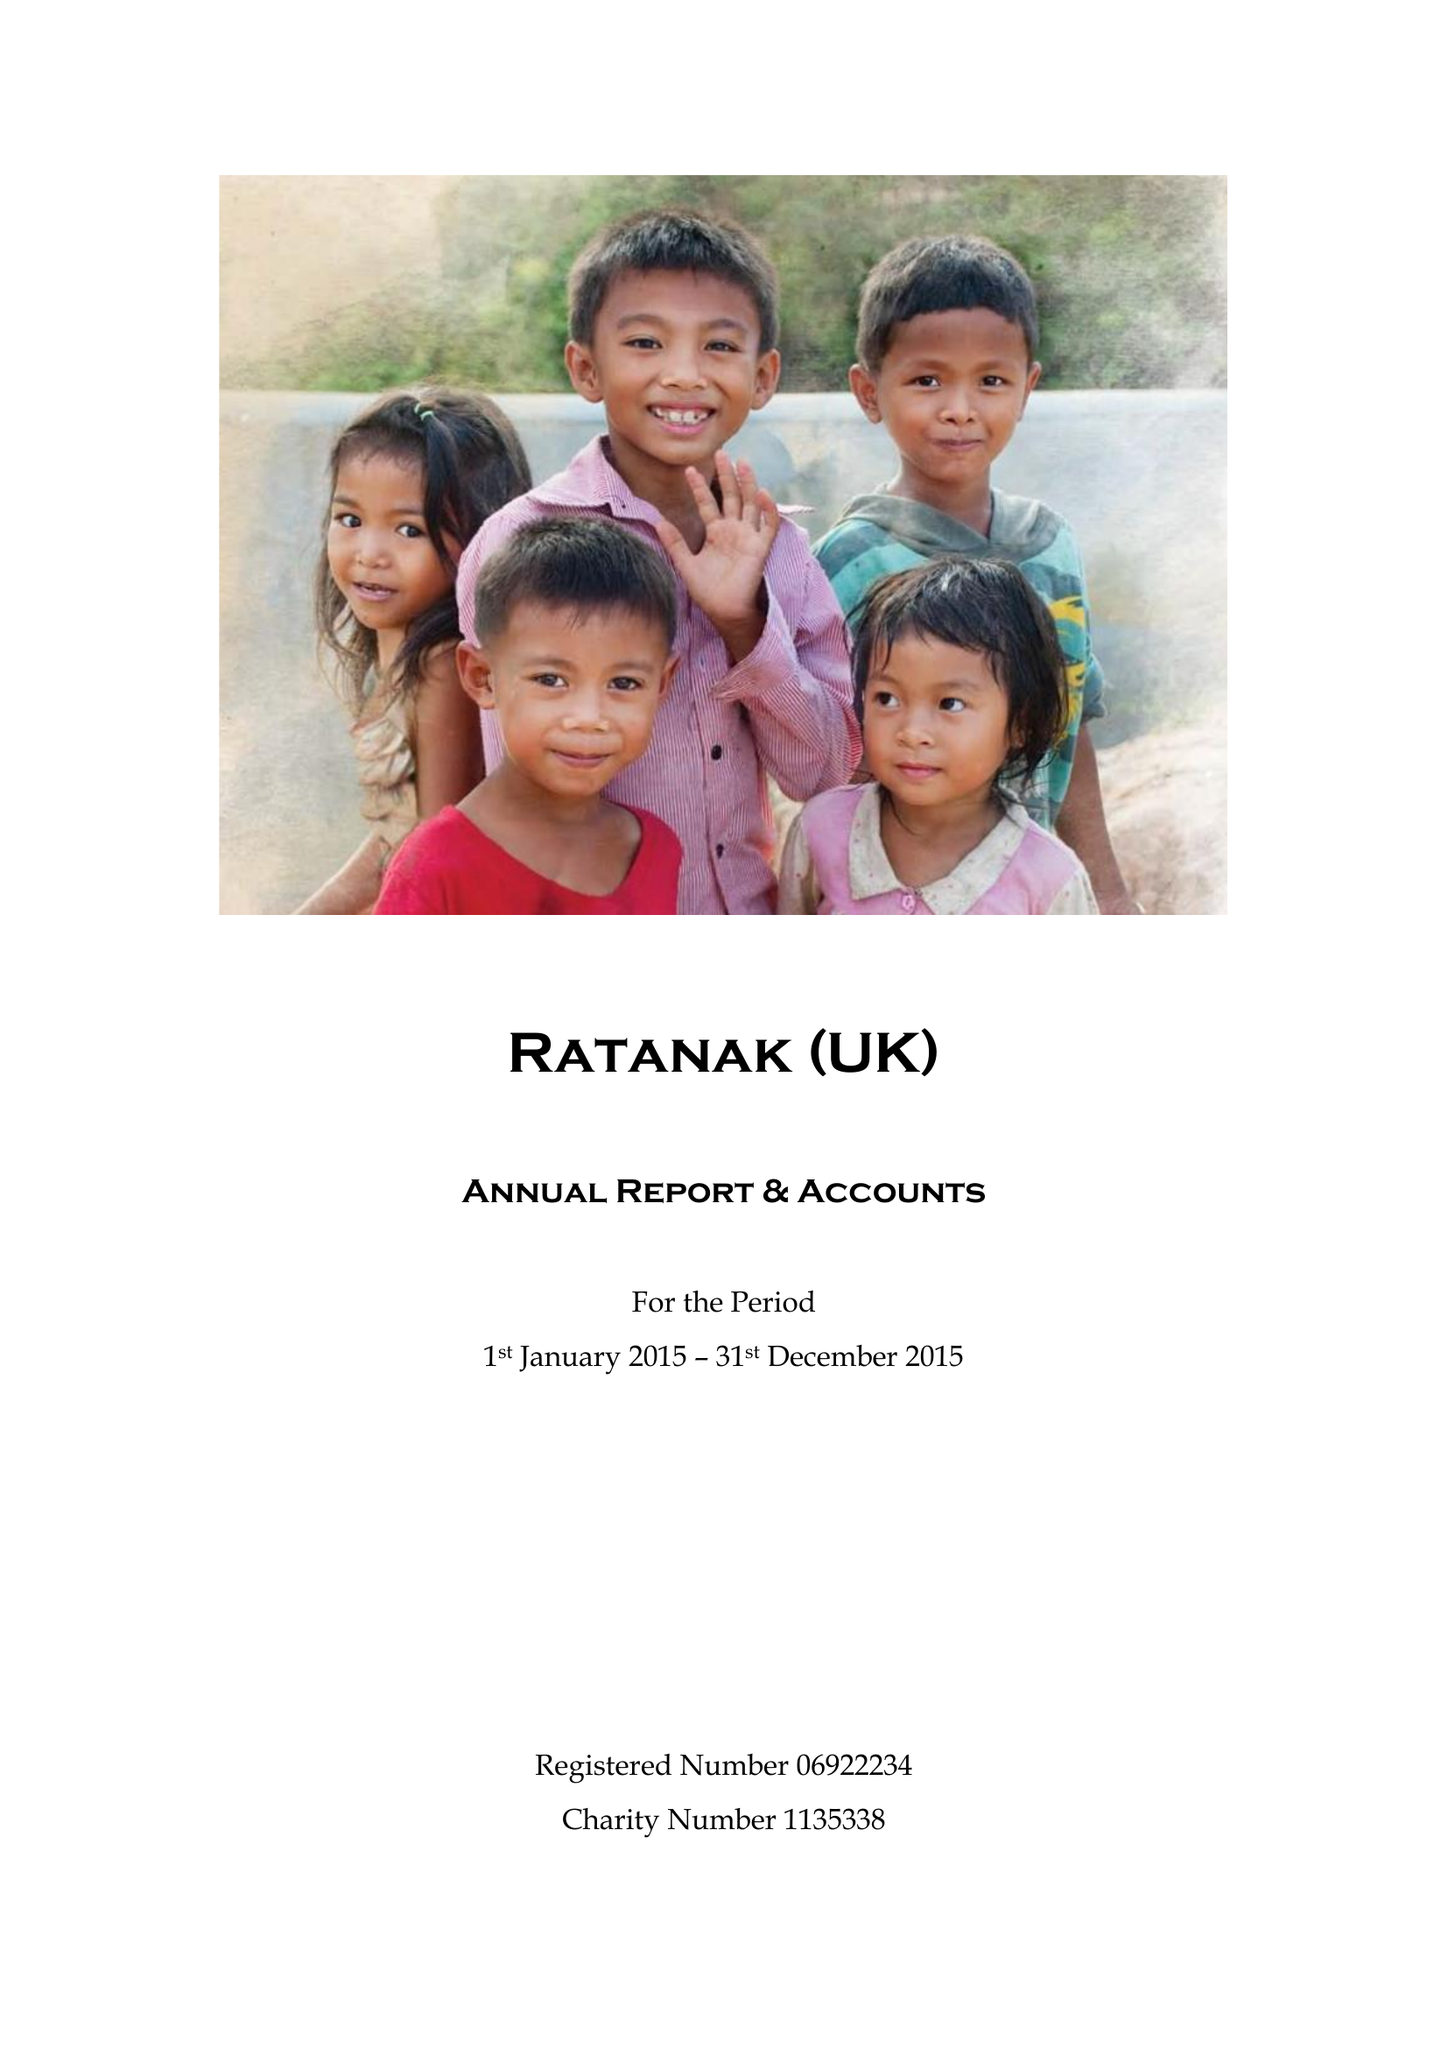What is the value for the address__post_town?
Answer the question using a single word or phrase. NORTHALLERTON 